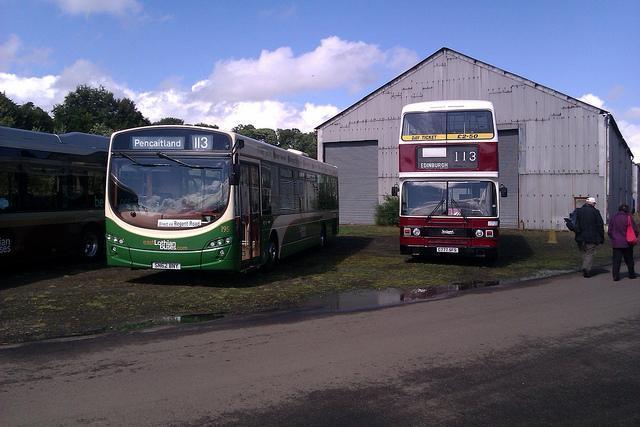How many buses are there?
Give a very brief answer. 2. How many buses are in the picture?
Give a very brief answer. 3. How many motorcycles in the picture?
Give a very brief answer. 0. 